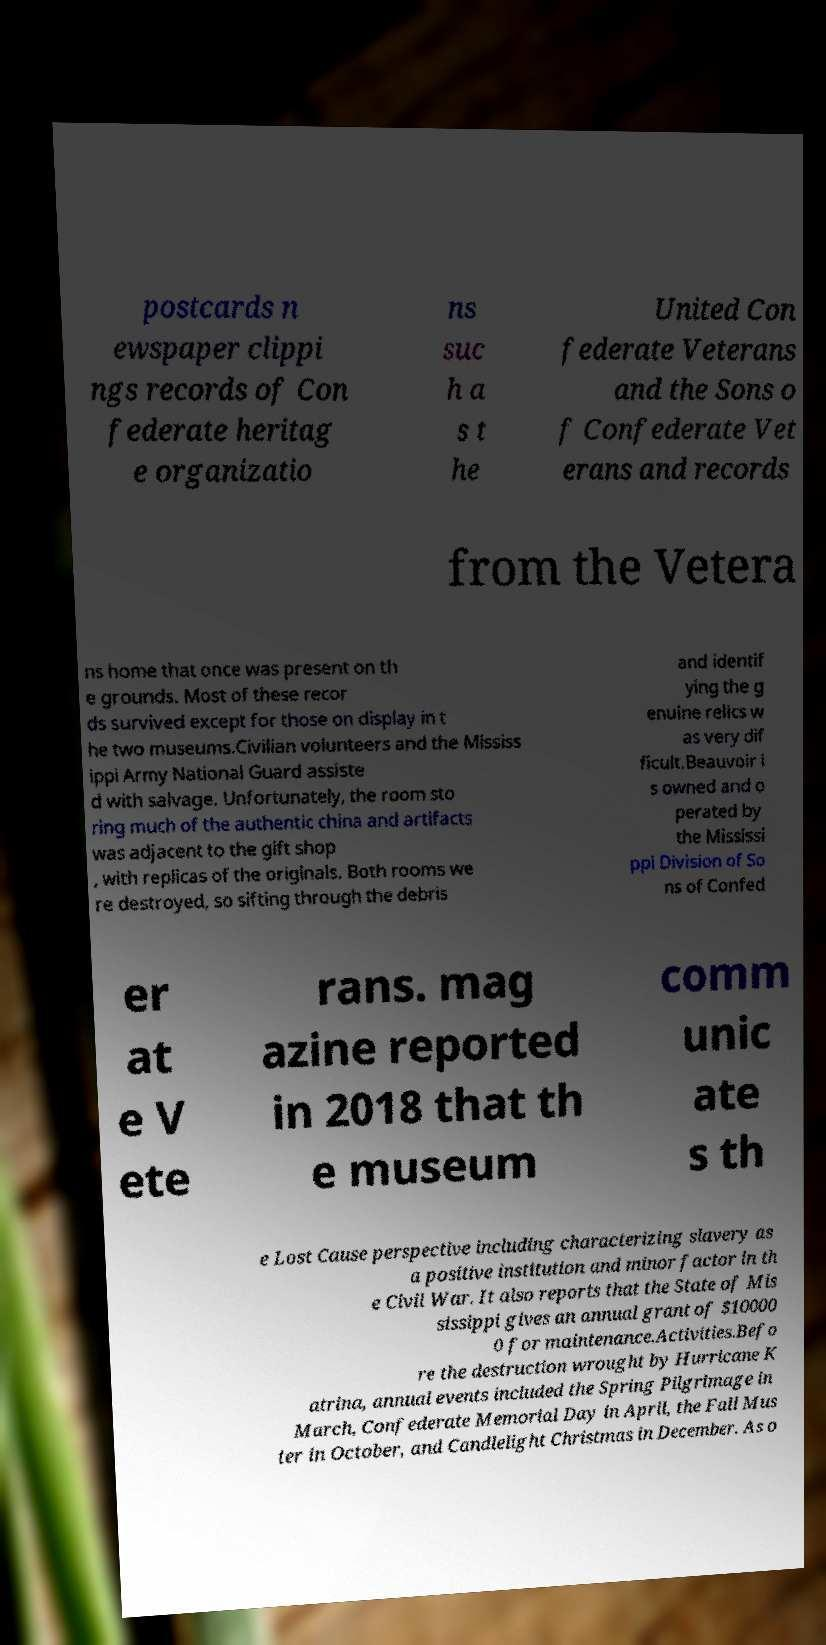Please read and relay the text visible in this image. What does it say? postcards n ewspaper clippi ngs records of Con federate heritag e organizatio ns suc h a s t he United Con federate Veterans and the Sons o f Confederate Vet erans and records from the Vetera ns home that once was present on th e grounds. Most of these recor ds survived except for those on display in t he two museums.Civilian volunteers and the Mississ ippi Army National Guard assiste d with salvage. Unfortunately, the room sto ring much of the authentic china and artifacts was adjacent to the gift shop , with replicas of the originals. Both rooms we re destroyed, so sifting through the debris and identif ying the g enuine relics w as very dif ficult.Beauvoir i s owned and o perated by the Mississi ppi Division of So ns of Confed er at e V ete rans. mag azine reported in 2018 that th e museum comm unic ate s th e Lost Cause perspective including characterizing slavery as a positive institution and minor factor in th e Civil War. It also reports that the State of Mis sissippi gives an annual grant of $10000 0 for maintenance.Activities.Befo re the destruction wrought by Hurricane K atrina, annual events included the Spring Pilgrimage in March, Confederate Memorial Day in April, the Fall Mus ter in October, and Candlelight Christmas in December. As o 